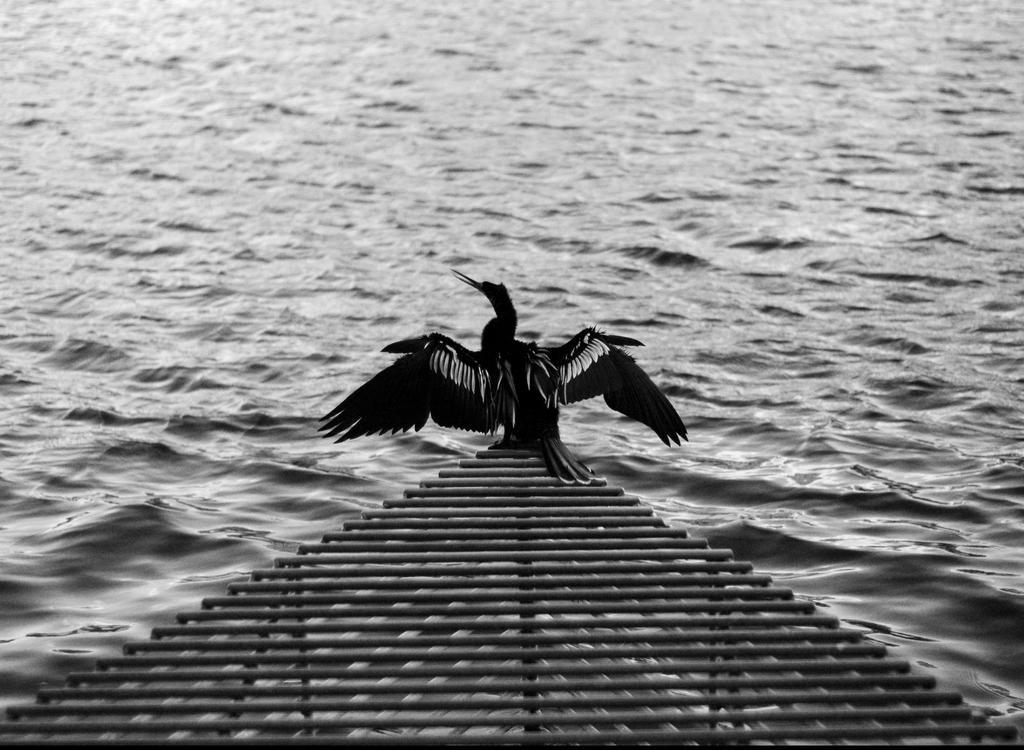Can you describe this image briefly? In this black and white image, we can see some water. There is a bird on the roof which is at the bottom of the image. 